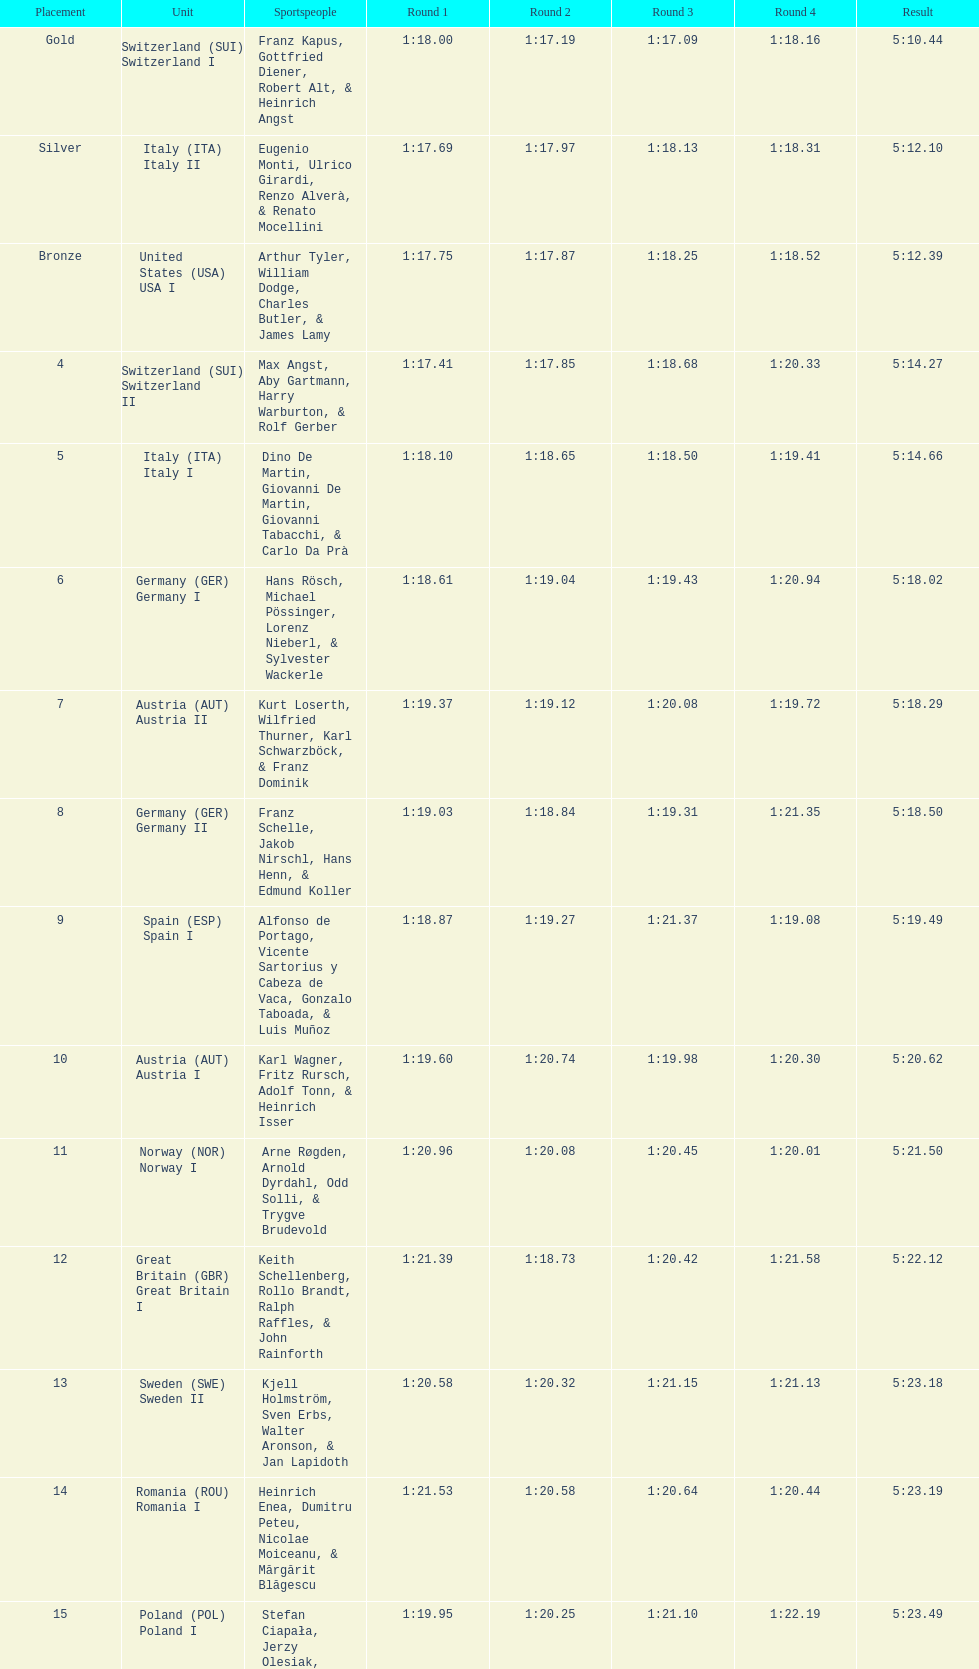Who is the previous team to italy (ita) italy ii? Switzerland (SUI) Switzerland I. 